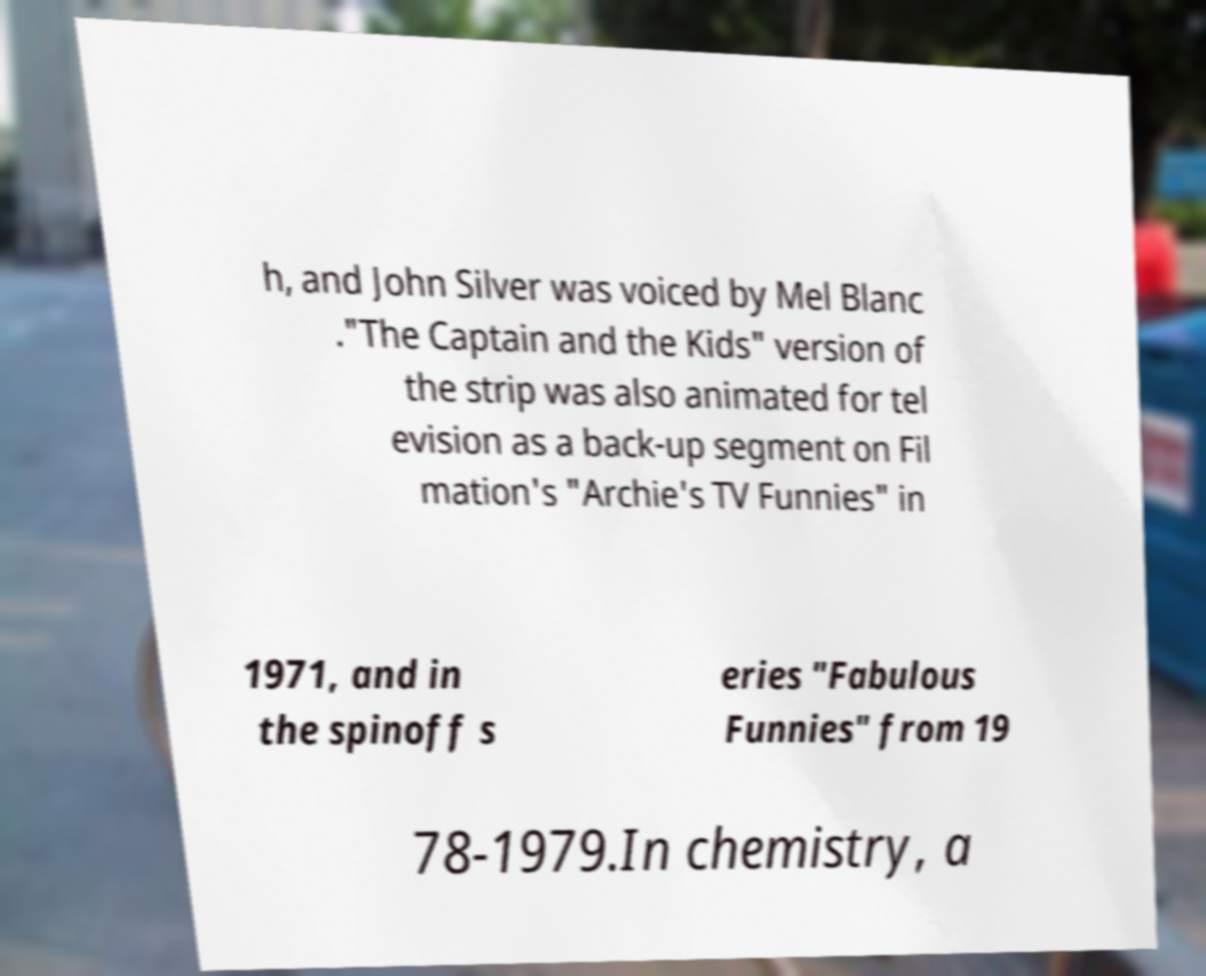Please read and relay the text visible in this image. What does it say? h, and John Silver was voiced by Mel Blanc ."The Captain and the Kids" version of the strip was also animated for tel evision as a back-up segment on Fil mation's "Archie's TV Funnies" in 1971, and in the spinoff s eries "Fabulous Funnies" from 19 78-1979.In chemistry, a 